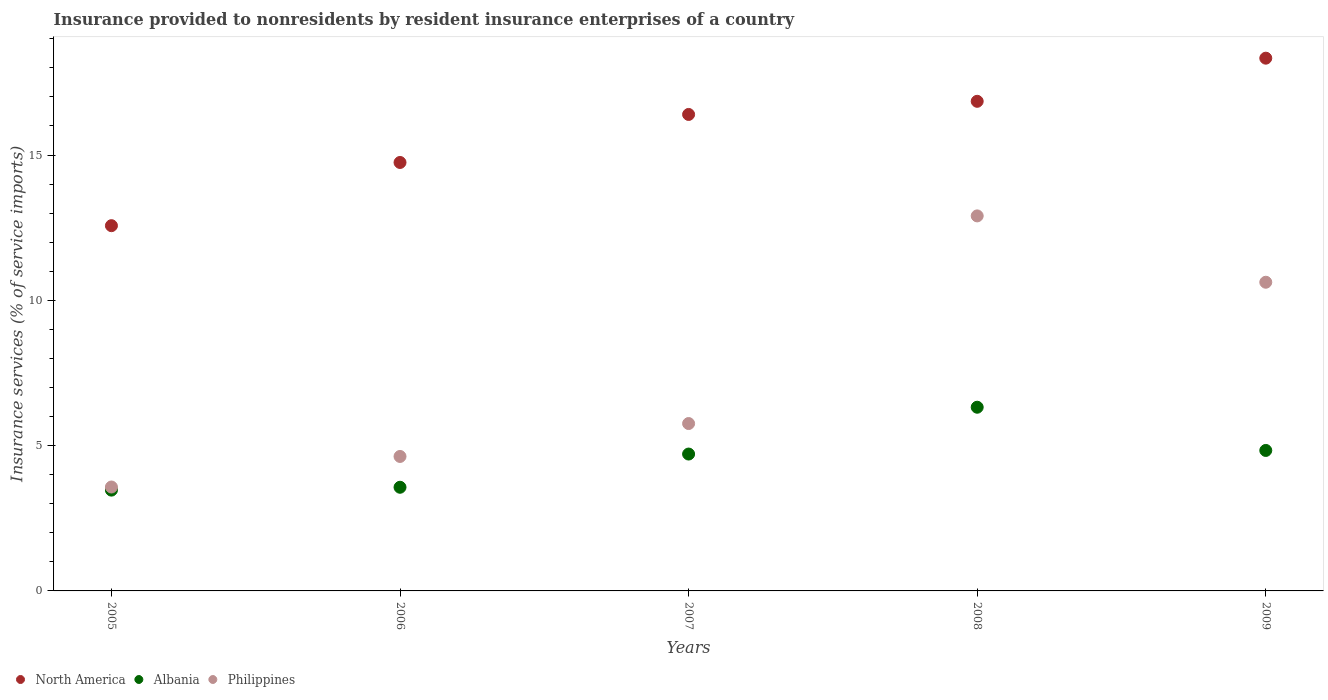How many different coloured dotlines are there?
Your answer should be compact. 3. What is the insurance provided to nonresidents in North America in 2006?
Your answer should be compact. 14.74. Across all years, what is the maximum insurance provided to nonresidents in North America?
Your answer should be very brief. 18.33. Across all years, what is the minimum insurance provided to nonresidents in North America?
Provide a succinct answer. 12.57. In which year was the insurance provided to nonresidents in Philippines maximum?
Provide a succinct answer. 2008. In which year was the insurance provided to nonresidents in North America minimum?
Your answer should be very brief. 2005. What is the total insurance provided to nonresidents in North America in the graph?
Provide a succinct answer. 78.89. What is the difference between the insurance provided to nonresidents in Albania in 2006 and that in 2009?
Your answer should be compact. -1.27. What is the difference between the insurance provided to nonresidents in Albania in 2005 and the insurance provided to nonresidents in Philippines in 2009?
Your answer should be compact. -7.15. What is the average insurance provided to nonresidents in Albania per year?
Your answer should be very brief. 4.58. In the year 2007, what is the difference between the insurance provided to nonresidents in North America and insurance provided to nonresidents in Philippines?
Your response must be concise. 10.64. What is the ratio of the insurance provided to nonresidents in North America in 2005 to that in 2009?
Your answer should be very brief. 0.69. Is the difference between the insurance provided to nonresidents in North America in 2007 and 2008 greater than the difference between the insurance provided to nonresidents in Philippines in 2007 and 2008?
Make the answer very short. Yes. What is the difference between the highest and the second highest insurance provided to nonresidents in Philippines?
Provide a short and direct response. 2.28. What is the difference between the highest and the lowest insurance provided to nonresidents in Albania?
Keep it short and to the point. 2.85. Does the insurance provided to nonresidents in North America monotonically increase over the years?
Ensure brevity in your answer.  Yes. How many dotlines are there?
Give a very brief answer. 3. Are the values on the major ticks of Y-axis written in scientific E-notation?
Give a very brief answer. No. Does the graph contain any zero values?
Keep it short and to the point. No. How many legend labels are there?
Your answer should be very brief. 3. How are the legend labels stacked?
Your answer should be very brief. Horizontal. What is the title of the graph?
Provide a succinct answer. Insurance provided to nonresidents by resident insurance enterprises of a country. What is the label or title of the Y-axis?
Your answer should be very brief. Insurance services (% of service imports). What is the Insurance services (% of service imports) of North America in 2005?
Make the answer very short. 12.57. What is the Insurance services (% of service imports) in Albania in 2005?
Make the answer very short. 3.47. What is the Insurance services (% of service imports) in Philippines in 2005?
Your response must be concise. 3.58. What is the Insurance services (% of service imports) in North America in 2006?
Provide a short and direct response. 14.74. What is the Insurance services (% of service imports) of Albania in 2006?
Provide a short and direct response. 3.57. What is the Insurance services (% of service imports) in Philippines in 2006?
Offer a terse response. 4.63. What is the Insurance services (% of service imports) of North America in 2007?
Offer a very short reply. 16.4. What is the Insurance services (% of service imports) in Albania in 2007?
Your response must be concise. 4.71. What is the Insurance services (% of service imports) in Philippines in 2007?
Keep it short and to the point. 5.76. What is the Insurance services (% of service imports) of North America in 2008?
Provide a succinct answer. 16.85. What is the Insurance services (% of service imports) of Albania in 2008?
Provide a succinct answer. 6.32. What is the Insurance services (% of service imports) of Philippines in 2008?
Offer a very short reply. 12.9. What is the Insurance services (% of service imports) in North America in 2009?
Provide a short and direct response. 18.33. What is the Insurance services (% of service imports) of Albania in 2009?
Your response must be concise. 4.83. What is the Insurance services (% of service imports) in Philippines in 2009?
Your response must be concise. 10.62. Across all years, what is the maximum Insurance services (% of service imports) of North America?
Give a very brief answer. 18.33. Across all years, what is the maximum Insurance services (% of service imports) in Albania?
Provide a short and direct response. 6.32. Across all years, what is the maximum Insurance services (% of service imports) in Philippines?
Provide a succinct answer. 12.9. Across all years, what is the minimum Insurance services (% of service imports) in North America?
Offer a very short reply. 12.57. Across all years, what is the minimum Insurance services (% of service imports) of Albania?
Provide a short and direct response. 3.47. Across all years, what is the minimum Insurance services (% of service imports) in Philippines?
Your answer should be very brief. 3.58. What is the total Insurance services (% of service imports) in North America in the graph?
Your response must be concise. 78.89. What is the total Insurance services (% of service imports) of Albania in the graph?
Provide a succinct answer. 22.9. What is the total Insurance services (% of service imports) in Philippines in the graph?
Ensure brevity in your answer.  37.49. What is the difference between the Insurance services (% of service imports) in North America in 2005 and that in 2006?
Your response must be concise. -2.17. What is the difference between the Insurance services (% of service imports) of Albania in 2005 and that in 2006?
Your response must be concise. -0.1. What is the difference between the Insurance services (% of service imports) in Philippines in 2005 and that in 2006?
Your answer should be compact. -1.05. What is the difference between the Insurance services (% of service imports) in North America in 2005 and that in 2007?
Provide a short and direct response. -3.83. What is the difference between the Insurance services (% of service imports) of Albania in 2005 and that in 2007?
Make the answer very short. -1.24. What is the difference between the Insurance services (% of service imports) of Philippines in 2005 and that in 2007?
Ensure brevity in your answer.  -2.18. What is the difference between the Insurance services (% of service imports) of North America in 2005 and that in 2008?
Your response must be concise. -4.28. What is the difference between the Insurance services (% of service imports) of Albania in 2005 and that in 2008?
Make the answer very short. -2.85. What is the difference between the Insurance services (% of service imports) of Philippines in 2005 and that in 2008?
Your response must be concise. -9.33. What is the difference between the Insurance services (% of service imports) in North America in 2005 and that in 2009?
Keep it short and to the point. -5.76. What is the difference between the Insurance services (% of service imports) in Albania in 2005 and that in 2009?
Provide a succinct answer. -1.37. What is the difference between the Insurance services (% of service imports) of Philippines in 2005 and that in 2009?
Provide a short and direct response. -7.05. What is the difference between the Insurance services (% of service imports) in North America in 2006 and that in 2007?
Your answer should be very brief. -1.65. What is the difference between the Insurance services (% of service imports) of Albania in 2006 and that in 2007?
Provide a succinct answer. -1.14. What is the difference between the Insurance services (% of service imports) of Philippines in 2006 and that in 2007?
Your response must be concise. -1.13. What is the difference between the Insurance services (% of service imports) of North America in 2006 and that in 2008?
Offer a terse response. -2.1. What is the difference between the Insurance services (% of service imports) in Albania in 2006 and that in 2008?
Give a very brief answer. -2.75. What is the difference between the Insurance services (% of service imports) of Philippines in 2006 and that in 2008?
Ensure brevity in your answer.  -8.28. What is the difference between the Insurance services (% of service imports) of North America in 2006 and that in 2009?
Give a very brief answer. -3.59. What is the difference between the Insurance services (% of service imports) of Albania in 2006 and that in 2009?
Your response must be concise. -1.27. What is the difference between the Insurance services (% of service imports) in Philippines in 2006 and that in 2009?
Offer a very short reply. -5.99. What is the difference between the Insurance services (% of service imports) in North America in 2007 and that in 2008?
Give a very brief answer. -0.45. What is the difference between the Insurance services (% of service imports) in Albania in 2007 and that in 2008?
Offer a very short reply. -1.61. What is the difference between the Insurance services (% of service imports) in Philippines in 2007 and that in 2008?
Offer a very short reply. -7.15. What is the difference between the Insurance services (% of service imports) of North America in 2007 and that in 2009?
Your response must be concise. -1.94. What is the difference between the Insurance services (% of service imports) of Albania in 2007 and that in 2009?
Keep it short and to the point. -0.12. What is the difference between the Insurance services (% of service imports) in Philippines in 2007 and that in 2009?
Your response must be concise. -4.86. What is the difference between the Insurance services (% of service imports) in North America in 2008 and that in 2009?
Your answer should be very brief. -1.48. What is the difference between the Insurance services (% of service imports) of Albania in 2008 and that in 2009?
Your answer should be very brief. 1.49. What is the difference between the Insurance services (% of service imports) in Philippines in 2008 and that in 2009?
Your answer should be very brief. 2.28. What is the difference between the Insurance services (% of service imports) of North America in 2005 and the Insurance services (% of service imports) of Albania in 2006?
Offer a very short reply. 9. What is the difference between the Insurance services (% of service imports) in North America in 2005 and the Insurance services (% of service imports) in Philippines in 2006?
Offer a very short reply. 7.94. What is the difference between the Insurance services (% of service imports) of Albania in 2005 and the Insurance services (% of service imports) of Philippines in 2006?
Offer a very short reply. -1.16. What is the difference between the Insurance services (% of service imports) of North America in 2005 and the Insurance services (% of service imports) of Albania in 2007?
Provide a short and direct response. 7.86. What is the difference between the Insurance services (% of service imports) of North America in 2005 and the Insurance services (% of service imports) of Philippines in 2007?
Offer a terse response. 6.81. What is the difference between the Insurance services (% of service imports) in Albania in 2005 and the Insurance services (% of service imports) in Philippines in 2007?
Your response must be concise. -2.29. What is the difference between the Insurance services (% of service imports) of North America in 2005 and the Insurance services (% of service imports) of Albania in 2008?
Your response must be concise. 6.25. What is the difference between the Insurance services (% of service imports) of North America in 2005 and the Insurance services (% of service imports) of Philippines in 2008?
Provide a succinct answer. -0.34. What is the difference between the Insurance services (% of service imports) of Albania in 2005 and the Insurance services (% of service imports) of Philippines in 2008?
Your response must be concise. -9.44. What is the difference between the Insurance services (% of service imports) of North America in 2005 and the Insurance services (% of service imports) of Albania in 2009?
Give a very brief answer. 7.73. What is the difference between the Insurance services (% of service imports) in North America in 2005 and the Insurance services (% of service imports) in Philippines in 2009?
Give a very brief answer. 1.95. What is the difference between the Insurance services (% of service imports) of Albania in 2005 and the Insurance services (% of service imports) of Philippines in 2009?
Your response must be concise. -7.15. What is the difference between the Insurance services (% of service imports) in North America in 2006 and the Insurance services (% of service imports) in Albania in 2007?
Your response must be concise. 10.03. What is the difference between the Insurance services (% of service imports) in North America in 2006 and the Insurance services (% of service imports) in Philippines in 2007?
Ensure brevity in your answer.  8.98. What is the difference between the Insurance services (% of service imports) of Albania in 2006 and the Insurance services (% of service imports) of Philippines in 2007?
Keep it short and to the point. -2.19. What is the difference between the Insurance services (% of service imports) in North America in 2006 and the Insurance services (% of service imports) in Albania in 2008?
Make the answer very short. 8.42. What is the difference between the Insurance services (% of service imports) of North America in 2006 and the Insurance services (% of service imports) of Philippines in 2008?
Ensure brevity in your answer.  1.84. What is the difference between the Insurance services (% of service imports) of Albania in 2006 and the Insurance services (% of service imports) of Philippines in 2008?
Your response must be concise. -9.34. What is the difference between the Insurance services (% of service imports) of North America in 2006 and the Insurance services (% of service imports) of Albania in 2009?
Make the answer very short. 9.91. What is the difference between the Insurance services (% of service imports) of North America in 2006 and the Insurance services (% of service imports) of Philippines in 2009?
Ensure brevity in your answer.  4.12. What is the difference between the Insurance services (% of service imports) of Albania in 2006 and the Insurance services (% of service imports) of Philippines in 2009?
Provide a succinct answer. -7.06. What is the difference between the Insurance services (% of service imports) of North America in 2007 and the Insurance services (% of service imports) of Albania in 2008?
Provide a succinct answer. 10.07. What is the difference between the Insurance services (% of service imports) of North America in 2007 and the Insurance services (% of service imports) of Philippines in 2008?
Provide a succinct answer. 3.49. What is the difference between the Insurance services (% of service imports) in Albania in 2007 and the Insurance services (% of service imports) in Philippines in 2008?
Make the answer very short. -8.2. What is the difference between the Insurance services (% of service imports) in North America in 2007 and the Insurance services (% of service imports) in Albania in 2009?
Offer a very short reply. 11.56. What is the difference between the Insurance services (% of service imports) in North America in 2007 and the Insurance services (% of service imports) in Philippines in 2009?
Make the answer very short. 5.77. What is the difference between the Insurance services (% of service imports) of Albania in 2007 and the Insurance services (% of service imports) of Philippines in 2009?
Provide a short and direct response. -5.91. What is the difference between the Insurance services (% of service imports) of North America in 2008 and the Insurance services (% of service imports) of Albania in 2009?
Keep it short and to the point. 12.01. What is the difference between the Insurance services (% of service imports) of North America in 2008 and the Insurance services (% of service imports) of Philippines in 2009?
Your answer should be very brief. 6.23. What is the difference between the Insurance services (% of service imports) in Albania in 2008 and the Insurance services (% of service imports) in Philippines in 2009?
Offer a terse response. -4.3. What is the average Insurance services (% of service imports) of North America per year?
Ensure brevity in your answer.  15.78. What is the average Insurance services (% of service imports) of Albania per year?
Give a very brief answer. 4.58. What is the average Insurance services (% of service imports) of Philippines per year?
Keep it short and to the point. 7.5. In the year 2005, what is the difference between the Insurance services (% of service imports) of North America and Insurance services (% of service imports) of Albania?
Offer a terse response. 9.1. In the year 2005, what is the difference between the Insurance services (% of service imports) of North America and Insurance services (% of service imports) of Philippines?
Keep it short and to the point. 8.99. In the year 2005, what is the difference between the Insurance services (% of service imports) of Albania and Insurance services (% of service imports) of Philippines?
Ensure brevity in your answer.  -0.11. In the year 2006, what is the difference between the Insurance services (% of service imports) of North America and Insurance services (% of service imports) of Albania?
Keep it short and to the point. 11.18. In the year 2006, what is the difference between the Insurance services (% of service imports) of North America and Insurance services (% of service imports) of Philippines?
Provide a succinct answer. 10.12. In the year 2006, what is the difference between the Insurance services (% of service imports) of Albania and Insurance services (% of service imports) of Philippines?
Your answer should be compact. -1.06. In the year 2007, what is the difference between the Insurance services (% of service imports) of North America and Insurance services (% of service imports) of Albania?
Provide a short and direct response. 11.69. In the year 2007, what is the difference between the Insurance services (% of service imports) of North America and Insurance services (% of service imports) of Philippines?
Your answer should be very brief. 10.64. In the year 2007, what is the difference between the Insurance services (% of service imports) in Albania and Insurance services (% of service imports) in Philippines?
Give a very brief answer. -1.05. In the year 2008, what is the difference between the Insurance services (% of service imports) in North America and Insurance services (% of service imports) in Albania?
Give a very brief answer. 10.53. In the year 2008, what is the difference between the Insurance services (% of service imports) of North America and Insurance services (% of service imports) of Philippines?
Your response must be concise. 3.94. In the year 2008, what is the difference between the Insurance services (% of service imports) in Albania and Insurance services (% of service imports) in Philippines?
Ensure brevity in your answer.  -6.58. In the year 2009, what is the difference between the Insurance services (% of service imports) in North America and Insurance services (% of service imports) in Albania?
Give a very brief answer. 13.5. In the year 2009, what is the difference between the Insurance services (% of service imports) of North America and Insurance services (% of service imports) of Philippines?
Your answer should be compact. 7.71. In the year 2009, what is the difference between the Insurance services (% of service imports) in Albania and Insurance services (% of service imports) in Philippines?
Your answer should be compact. -5.79. What is the ratio of the Insurance services (% of service imports) in North America in 2005 to that in 2006?
Provide a succinct answer. 0.85. What is the ratio of the Insurance services (% of service imports) in Albania in 2005 to that in 2006?
Provide a succinct answer. 0.97. What is the ratio of the Insurance services (% of service imports) in Philippines in 2005 to that in 2006?
Ensure brevity in your answer.  0.77. What is the ratio of the Insurance services (% of service imports) of North America in 2005 to that in 2007?
Provide a succinct answer. 0.77. What is the ratio of the Insurance services (% of service imports) in Albania in 2005 to that in 2007?
Offer a very short reply. 0.74. What is the ratio of the Insurance services (% of service imports) in Philippines in 2005 to that in 2007?
Your response must be concise. 0.62. What is the ratio of the Insurance services (% of service imports) of North America in 2005 to that in 2008?
Offer a terse response. 0.75. What is the ratio of the Insurance services (% of service imports) of Albania in 2005 to that in 2008?
Provide a succinct answer. 0.55. What is the ratio of the Insurance services (% of service imports) in Philippines in 2005 to that in 2008?
Keep it short and to the point. 0.28. What is the ratio of the Insurance services (% of service imports) of North America in 2005 to that in 2009?
Give a very brief answer. 0.69. What is the ratio of the Insurance services (% of service imports) of Albania in 2005 to that in 2009?
Ensure brevity in your answer.  0.72. What is the ratio of the Insurance services (% of service imports) of Philippines in 2005 to that in 2009?
Ensure brevity in your answer.  0.34. What is the ratio of the Insurance services (% of service imports) in North America in 2006 to that in 2007?
Your response must be concise. 0.9. What is the ratio of the Insurance services (% of service imports) of Albania in 2006 to that in 2007?
Provide a succinct answer. 0.76. What is the ratio of the Insurance services (% of service imports) of Philippines in 2006 to that in 2007?
Make the answer very short. 0.8. What is the ratio of the Insurance services (% of service imports) in North America in 2006 to that in 2008?
Your answer should be very brief. 0.88. What is the ratio of the Insurance services (% of service imports) of Albania in 2006 to that in 2008?
Make the answer very short. 0.56. What is the ratio of the Insurance services (% of service imports) of Philippines in 2006 to that in 2008?
Offer a very short reply. 0.36. What is the ratio of the Insurance services (% of service imports) of North America in 2006 to that in 2009?
Your answer should be compact. 0.8. What is the ratio of the Insurance services (% of service imports) in Albania in 2006 to that in 2009?
Your answer should be very brief. 0.74. What is the ratio of the Insurance services (% of service imports) of Philippines in 2006 to that in 2009?
Keep it short and to the point. 0.44. What is the ratio of the Insurance services (% of service imports) of North America in 2007 to that in 2008?
Provide a short and direct response. 0.97. What is the ratio of the Insurance services (% of service imports) in Albania in 2007 to that in 2008?
Ensure brevity in your answer.  0.75. What is the ratio of the Insurance services (% of service imports) in Philippines in 2007 to that in 2008?
Offer a very short reply. 0.45. What is the ratio of the Insurance services (% of service imports) of North America in 2007 to that in 2009?
Your answer should be compact. 0.89. What is the ratio of the Insurance services (% of service imports) in Albania in 2007 to that in 2009?
Provide a succinct answer. 0.97. What is the ratio of the Insurance services (% of service imports) of Philippines in 2007 to that in 2009?
Your answer should be compact. 0.54. What is the ratio of the Insurance services (% of service imports) in North America in 2008 to that in 2009?
Give a very brief answer. 0.92. What is the ratio of the Insurance services (% of service imports) of Albania in 2008 to that in 2009?
Make the answer very short. 1.31. What is the ratio of the Insurance services (% of service imports) in Philippines in 2008 to that in 2009?
Provide a short and direct response. 1.21. What is the difference between the highest and the second highest Insurance services (% of service imports) of North America?
Provide a short and direct response. 1.48. What is the difference between the highest and the second highest Insurance services (% of service imports) in Albania?
Ensure brevity in your answer.  1.49. What is the difference between the highest and the second highest Insurance services (% of service imports) in Philippines?
Your answer should be compact. 2.28. What is the difference between the highest and the lowest Insurance services (% of service imports) in North America?
Offer a terse response. 5.76. What is the difference between the highest and the lowest Insurance services (% of service imports) of Albania?
Give a very brief answer. 2.85. What is the difference between the highest and the lowest Insurance services (% of service imports) of Philippines?
Keep it short and to the point. 9.33. 